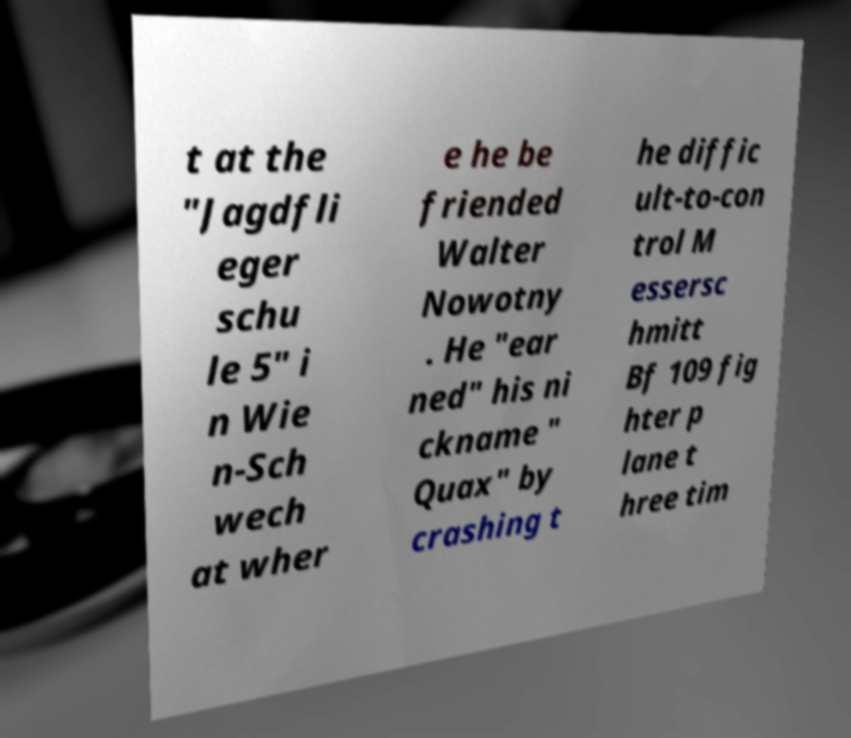Could you assist in decoding the text presented in this image and type it out clearly? t at the "Jagdfli eger schu le 5" i n Wie n-Sch wech at wher e he be friended Walter Nowotny . He "ear ned" his ni ckname " Quax" by crashing t he diffic ult-to-con trol M essersc hmitt Bf 109 fig hter p lane t hree tim 